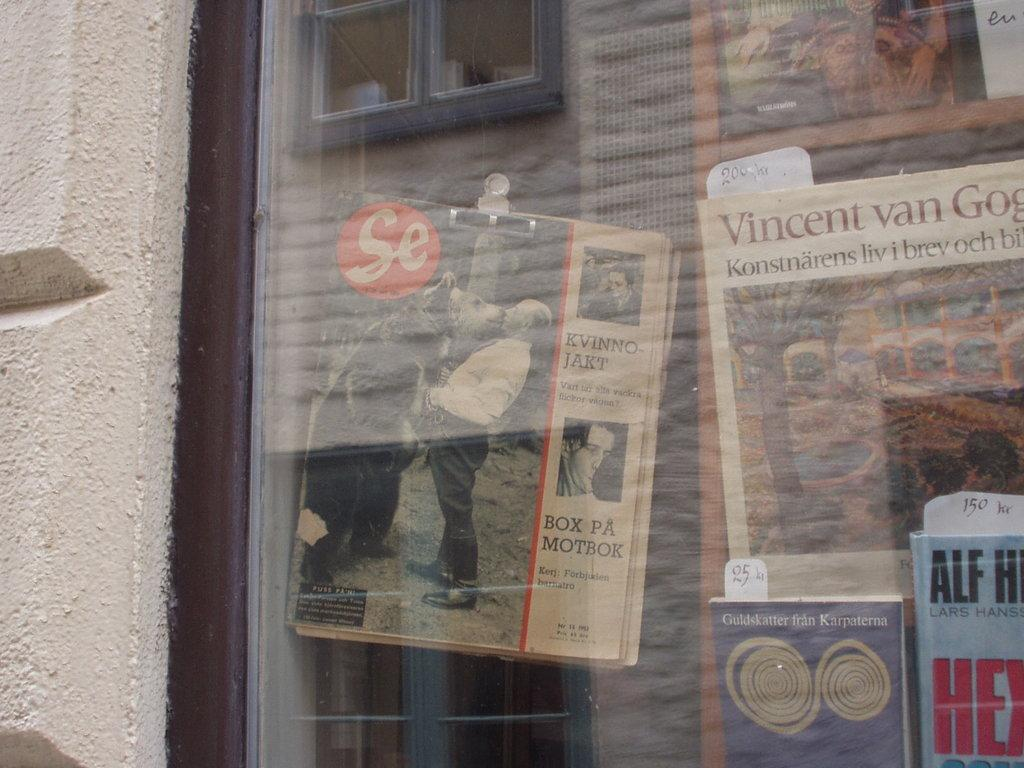What can be seen in the image that is typically used for drinking? There is a glass in the image. What is being used to hold multiple papers together in the image? There are papers with a clip in the image. What type of reading material is visible in the image? There are books in the image. Can you describe any other items present in the image? There are other items in the image, but their specific details are not mentioned in the provided facts. What is the source of the reflection in the image? There is a reflection of a window in the image. What type of throat condition can be seen in the image? There is no mention of any throat condition in the image. What is the best way to travel to the north in the image? There is no information about traveling or directions in the image. 